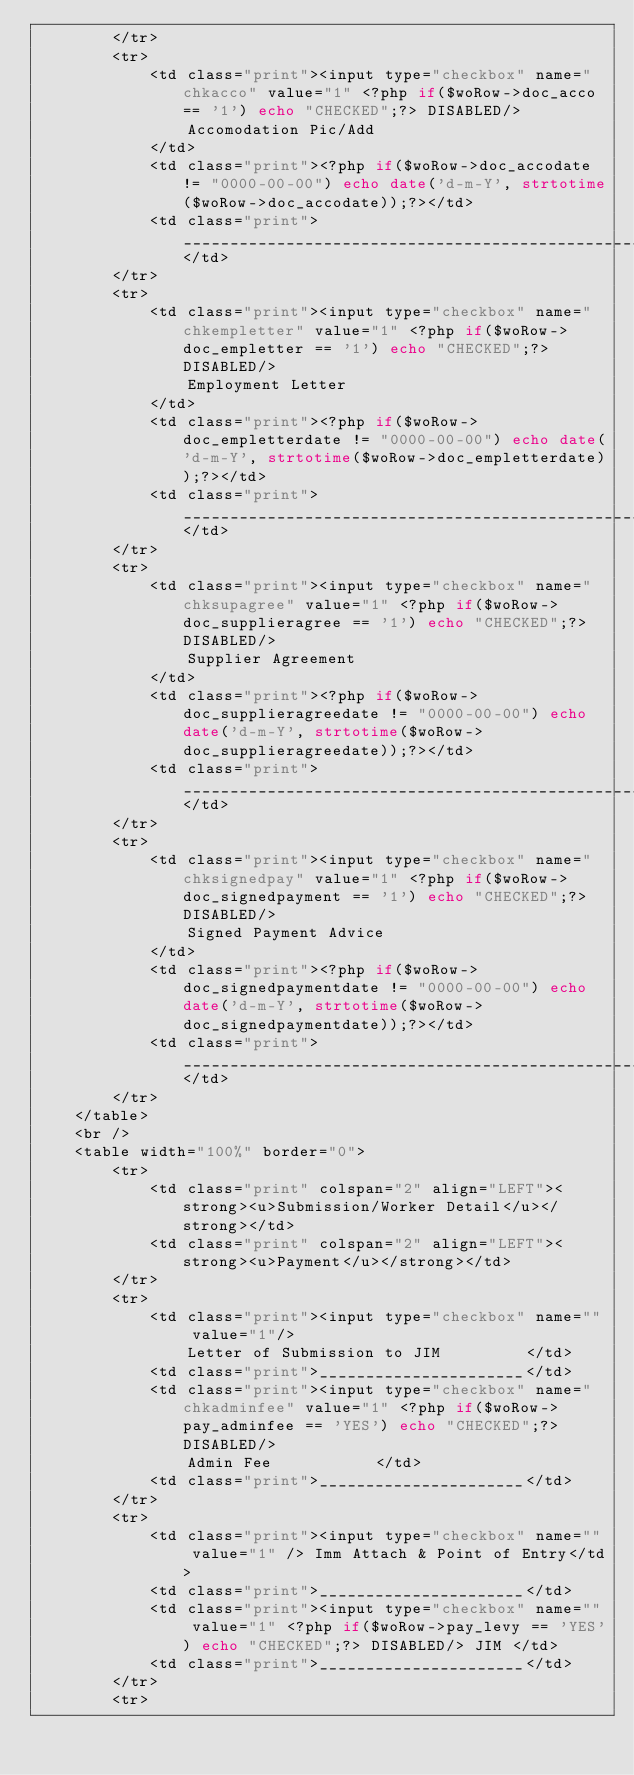Convert code to text. <code><loc_0><loc_0><loc_500><loc_500><_PHP_>		</tr>
		<tr>
			<td class="print"><input type="checkbox" name="chkacco" value="1" <?php if($woRow->doc_acco == '1') echo "CHECKED";?> DISABLED/>
				Accomodation Pic/Add
			</td>
			<td class="print"><?php if($woRow->doc_accodate != "0000-00-00") echo date('d-m-Y', strtotime($woRow->doc_accodate));?></td>
			<td class="print">_________________________________________________</td>
		</tr>
		<tr>
			<td class="print"><input type="checkbox" name="chkempletter" value="1" <?php if($woRow->doc_empletter == '1') echo "CHECKED";?> DISABLED/>
				Employment Letter
			</td>
			<td class="print"><?php if($woRow->doc_empletterdate != "0000-00-00") echo date('d-m-Y', strtotime($woRow->doc_empletterdate));?></td>
			<td class="print">_________________________________________________</td>
		</tr>
		<tr>
			<td class="print"><input type="checkbox" name="chksupagree" value="1" <?php if($woRow->doc_supplieragree == '1') echo "CHECKED";?> DISABLED/>
				Supplier Agreement
			</td>
			<td class="print"><?php if($woRow->doc_supplieragreedate != "0000-00-00") echo date('d-m-Y', strtotime($woRow->doc_supplieragreedate));?></td>
			<td class="print">_________________________________________________</td>
		</tr>
		<tr>
			<td class="print"><input type="checkbox" name="chksignedpay" value="1" <?php if($woRow->doc_signedpayment == '1') echo "CHECKED";?> DISABLED/>
				Signed Payment Advice
			</td>
			<td class="print"><?php if($woRow->doc_signedpaymentdate != "0000-00-00") echo date('d-m-Y', strtotime($woRow->doc_signedpaymentdate));?></td>
			<td class="print">_________________________________________________</td>
		</tr>
	</table>
	<br />
	<table width="100%" border="0">
		<tr>
			<td class="print" colspan="2" align="LEFT"><strong><u>Submission/Worker Detail</u></strong></td>
			<td class="print" colspan="2" align="LEFT"><strong><u>Payment</u></strong></td>
		</tr>
		<tr>
			<td class="print"><input type="checkbox" name="" value="1"/>
				Letter of Submission to JIM			</td>
			<td class="print">______________________</td>
			<td class="print"><input type="checkbox" name="chkadminfee" value="1" <?php if($woRow->pay_adminfee == 'YES') echo "CHECKED";?> DISABLED/>
				Admin Fee			</td>
			<td class="print">______________________</td>
		</tr>
		<tr>
			<td class="print"><input type="checkbox" name="" value="1" /> Imm Attach & Point of Entry</td>
			<td class="print">______________________</td>
			<td class="print"><input type="checkbox" name="" value="1" <?php if($woRow->pay_levy == 'YES') echo "CHECKED";?> DISABLED/> JIM </td>
			<td class="print">______________________</td>
		</tr>
		<tr></code> 